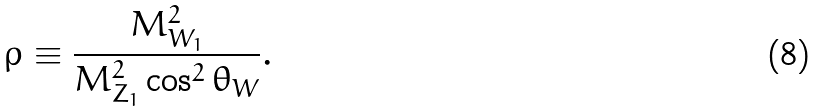<formula> <loc_0><loc_0><loc_500><loc_500>\rho \equiv \frac { M _ { W _ { 1 } } ^ { 2 } } { M _ { Z _ { 1 } } ^ { 2 } \cos ^ { 2 } \theta _ { W } } .</formula> 